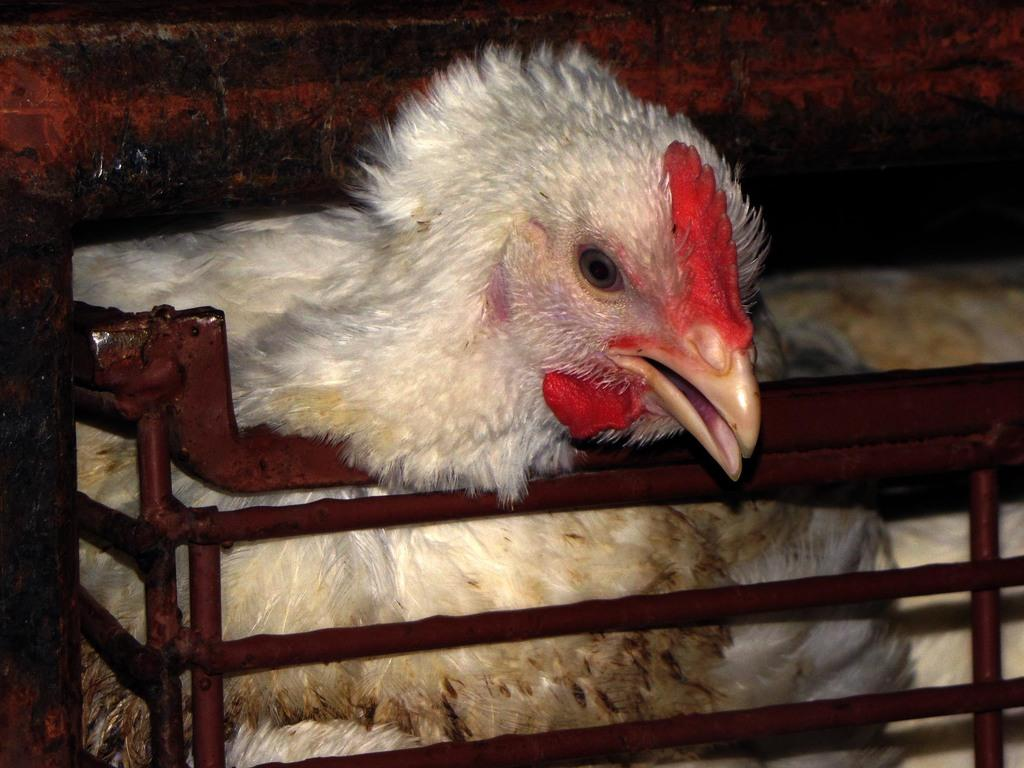What animal is the main subject of the picture? There is a hen in the picture. What is the hen's position in relation to the fences? The hen has a fence below its head and a fence above its head. What type of cream can be seen on the hen's feathers in the image? There is no cream present on the hen's feathers in the image. How does the hen taste the thread in the image? There is no thread present in the image, and hens do not taste or interact with thread. 